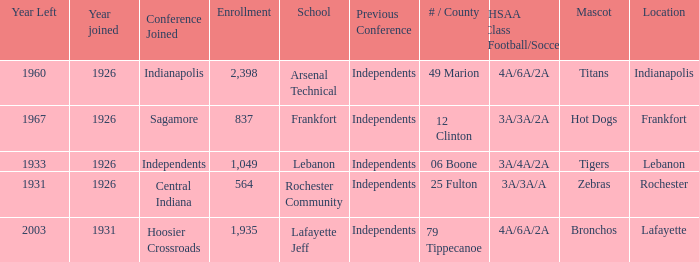What is the lowest enrollment that has Lafayette as the location? 1935.0. 